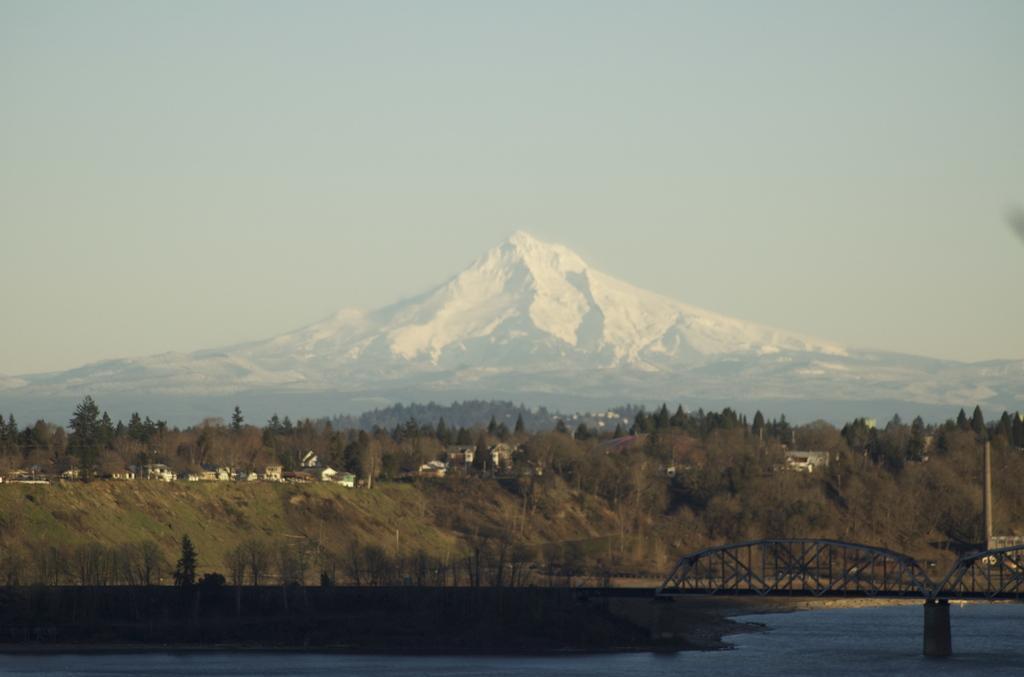Describe this image in one or two sentences. In the picture we can see a water and far from it, we can see some plants, trees, hills with some plants, trees and houses and in the background we can see a mountain covered with a snow and a sky. 